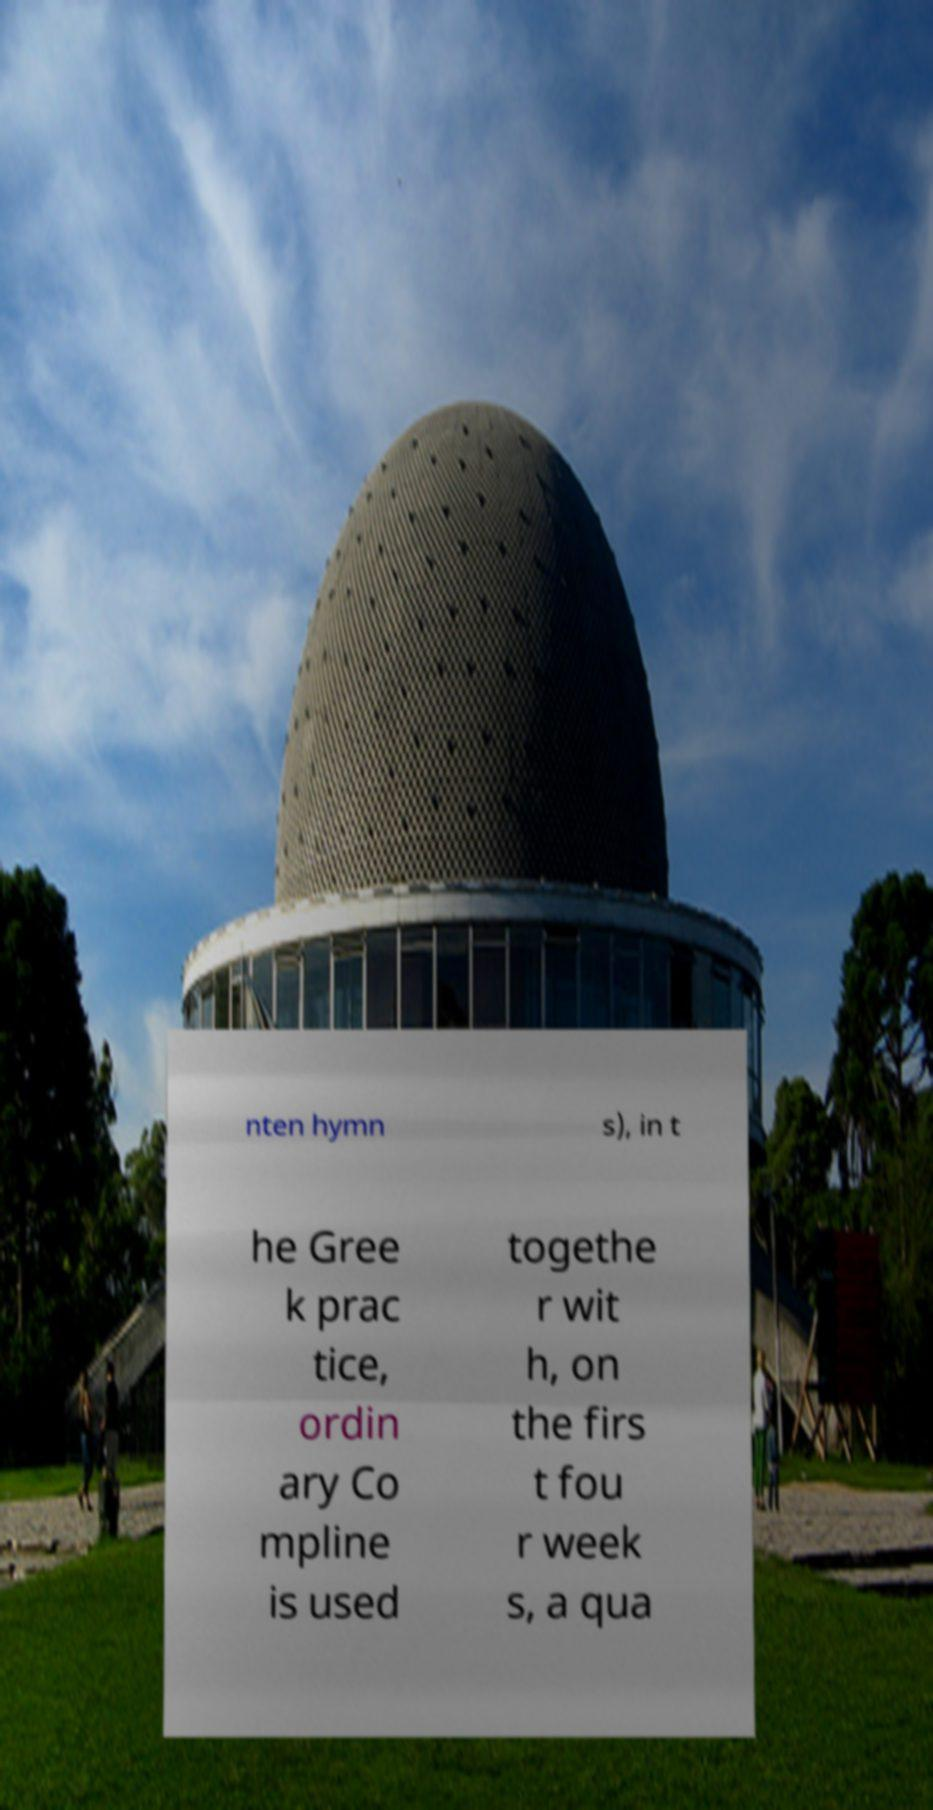For documentation purposes, I need the text within this image transcribed. Could you provide that? nten hymn s), in t he Gree k prac tice, ordin ary Co mpline is used togethe r wit h, on the firs t fou r week s, a qua 